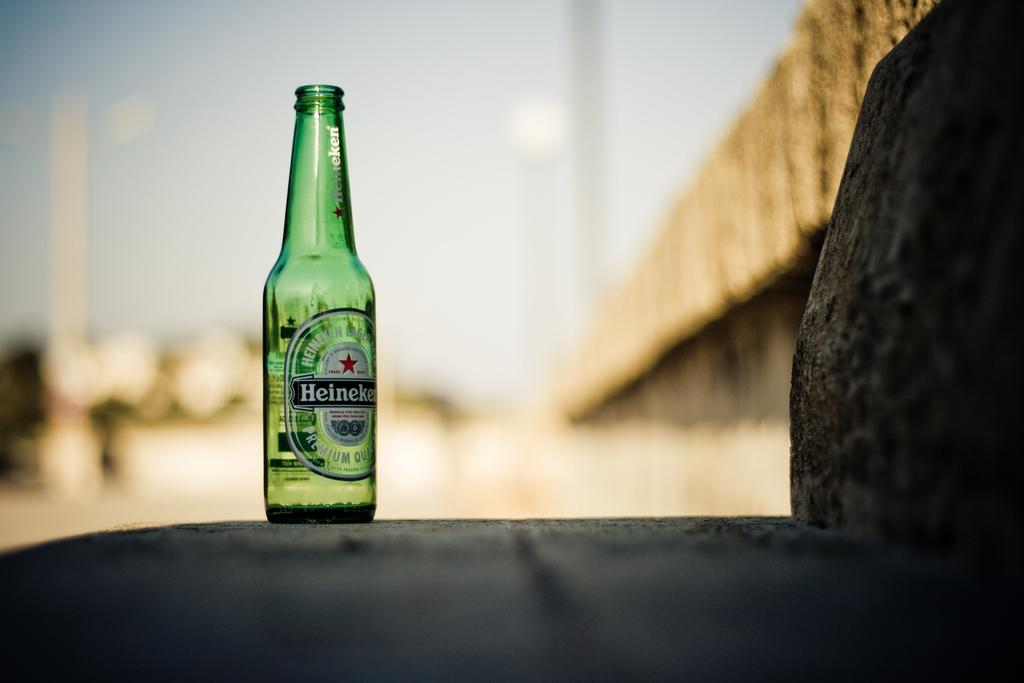<image>
Render a clear and concise summary of the photo. a bottle of heineken that is open and on a rock 